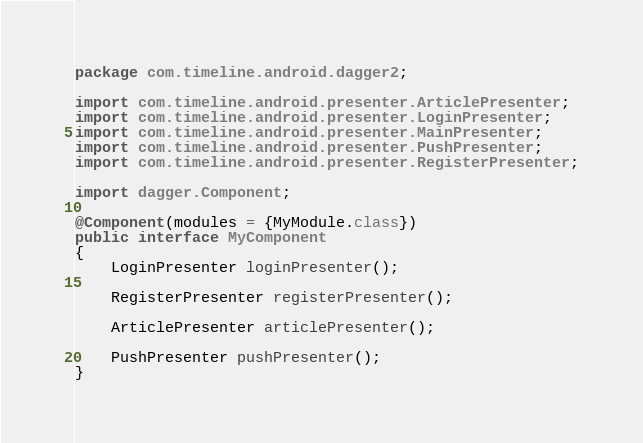<code> <loc_0><loc_0><loc_500><loc_500><_Java_>package com.timeline.android.dagger2;

import com.timeline.android.presenter.ArticlePresenter;
import com.timeline.android.presenter.LoginPresenter;
import com.timeline.android.presenter.MainPresenter;
import com.timeline.android.presenter.PushPresenter;
import com.timeline.android.presenter.RegisterPresenter;

import dagger.Component;

@Component(modules = {MyModule.class})
public interface MyComponent
{
    LoginPresenter loginPresenter();

    RegisterPresenter registerPresenter();

    ArticlePresenter articlePresenter();

    PushPresenter pushPresenter();
}
</code> 